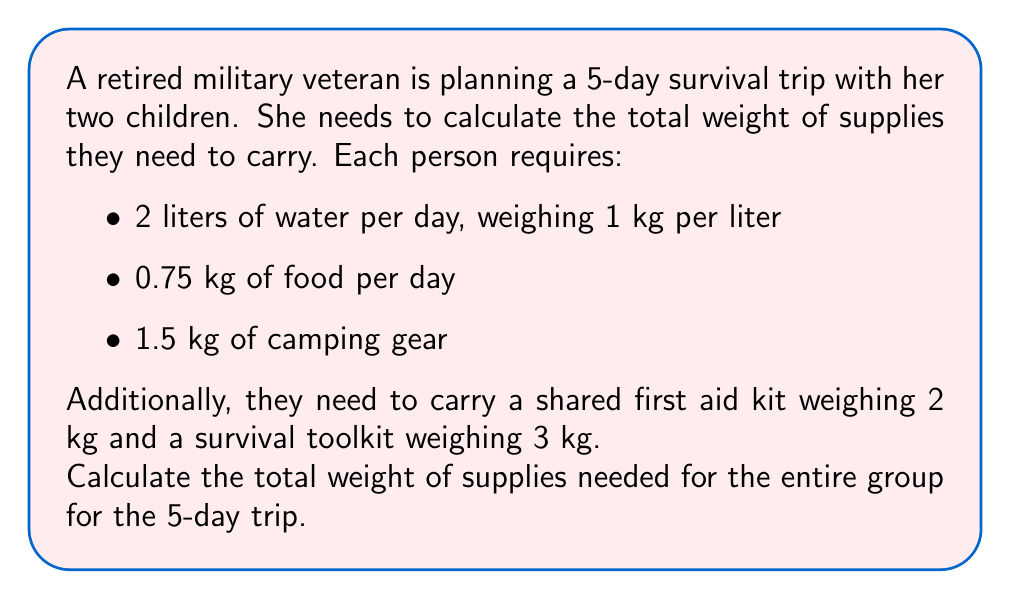Provide a solution to this math problem. Let's break this problem down step by step:

1. Calculate water weight per person:
   $$ \text{Water weight} = 5 \text{ days} \times 2 \text{ liters/day} \times 1 \text{ kg/liter} = 10 \text{ kg} $$

2. Calculate food weight per person:
   $$ \text{Food weight} = 5 \text{ days} \times 0.75 \text{ kg/day} = 3.75 \text{ kg} $$

3. Total weight per person:
   $$ \text{Weight per person} = 10 \text{ kg (water)} + 3.75 \text{ kg (food)} + 1.5 \text{ kg (camping gear)} = 15.25 \text{ kg} $$

4. Total weight for all three people:
   $$ \text{Total group weight} = 3 \times 15.25 \text{ kg} = 45.75 \text{ kg} $$

5. Add shared items:
   $$ \text{Shared items} = 2 \text{ kg (first aid kit)} + 3 \text{ kg (survival toolkit)} = 5 \text{ kg} $$

6. Calculate total weight:
   $$ \text{Total weight} = 45.75 \text{ kg (group supplies)} + 5 \text{ kg (shared items)} = 50.75 \text{ kg} $$

Therefore, the total weight of supplies needed for the entire group for the 5-day trip is 50.75 kg.
Answer: 50.75 kg 